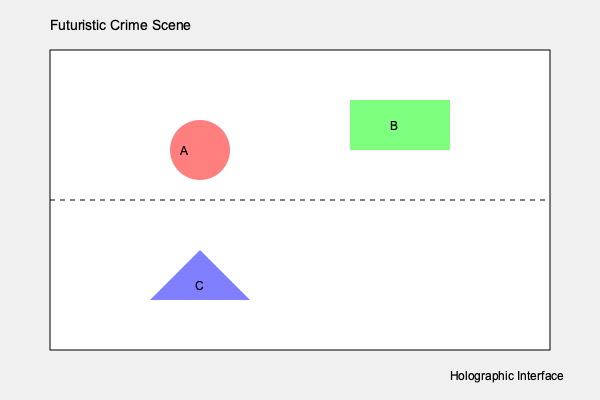In the futuristic crime scene diagram, three pieces of evidence are marked A, B, and C. Based on their shapes and colors, which piece of evidence is most likely to be a holographic projection of the perpetrator's last known location? To determine which piece of evidence is most likely a holographic projection of the perpetrator's last known location, let's analyze each piece of evidence:

1. Evidence A (red circle):
   - Circular shape suggests a defined area of interest
   - Red color often indicates danger or importance
   - Opacity suggests it may be a projection

2. Evidence B (green rectangle):
   - Rectangular shape could represent a physical object or screen
   - Green color might indicate a safe or cleared area
   - Less likely to be a holographic projection of a person

3. Evidence C (blue triangle):
   - Triangular shape is unusual for representing a person
   - Blue color is often associated with technology or data
   - The shape and color don't align well with a person's projection

Given the futuristic setting and the question's focus on holographic technology:

- Evidence A is the most likely candidate for a holographic projection of the perpetrator's last known location.
- Its circular shape could represent the area where the perpetrator was detected.
- The red color emphasizes its importance in the investigation.
- The semi-transparent appearance (opacity) is consistent with holographic technology.

Therefore, Evidence A is the most probable choice for a holographic projection of the perpetrator's last known location in this futuristic crime scene.
Answer: Evidence A 